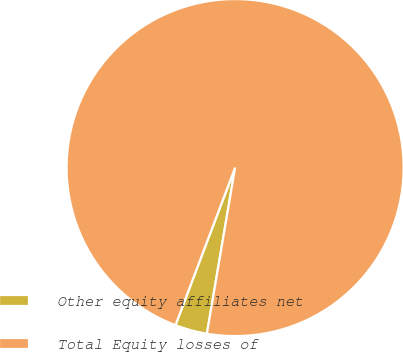<chart> <loc_0><loc_0><loc_500><loc_500><pie_chart><fcel>Other equity affiliates net<fcel>Total Equity losses of<nl><fcel>3.08%<fcel>96.92%<nl></chart> 